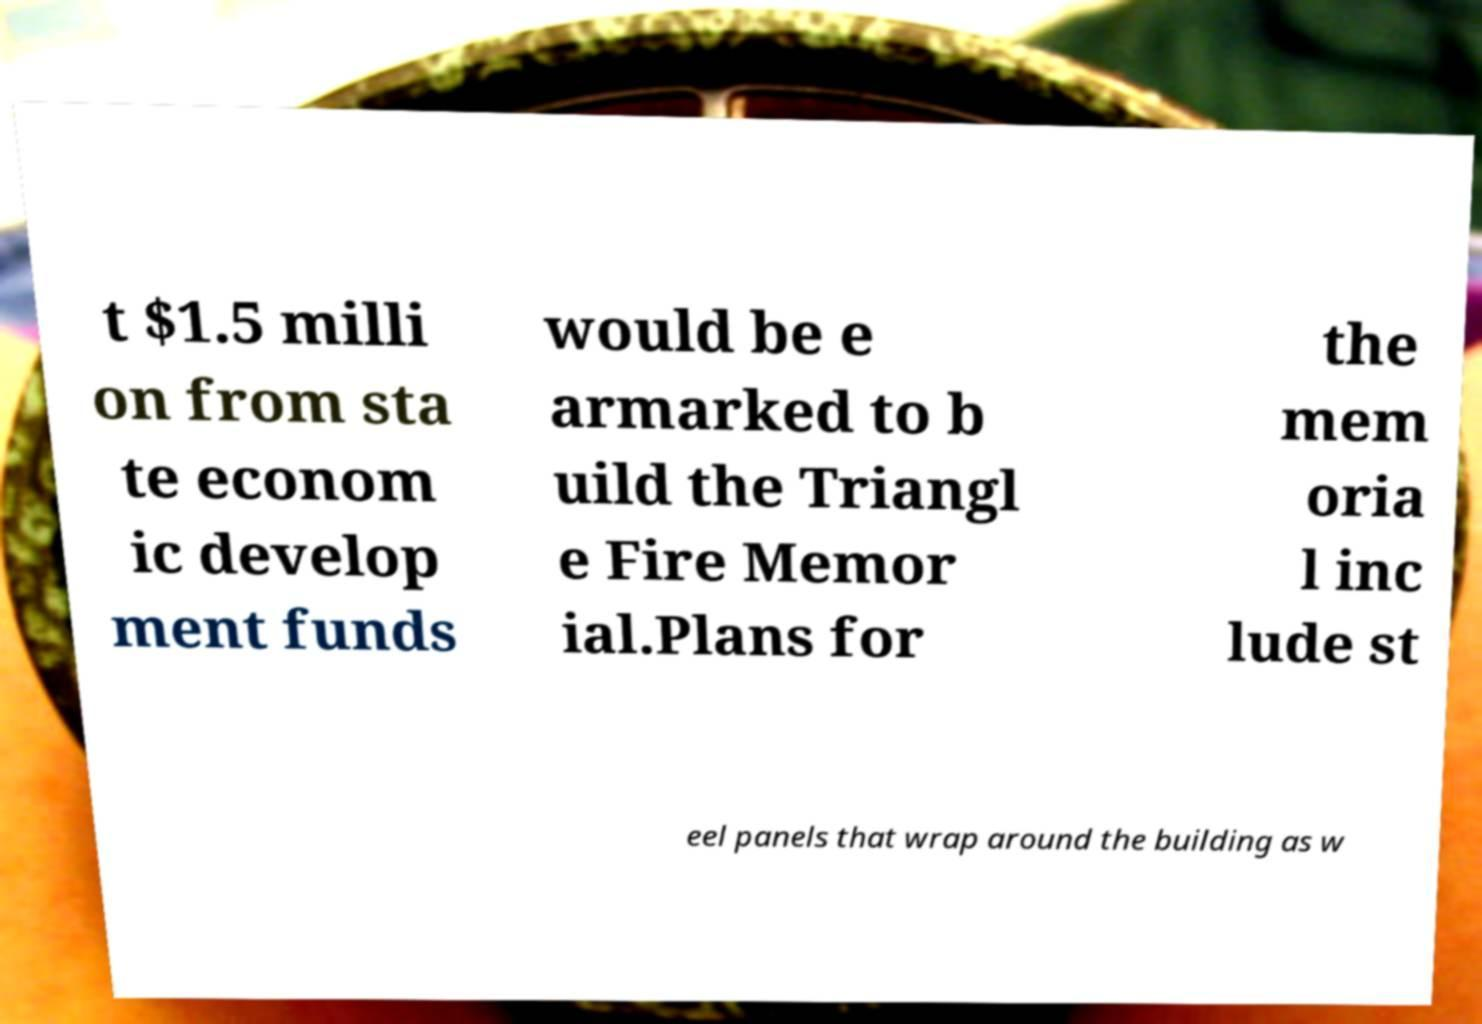What messages or text are displayed in this image? I need them in a readable, typed format. t $1.5 milli on from sta te econom ic develop ment funds would be e armarked to b uild the Triangl e Fire Memor ial.Plans for the mem oria l inc lude st eel panels that wrap around the building as w 